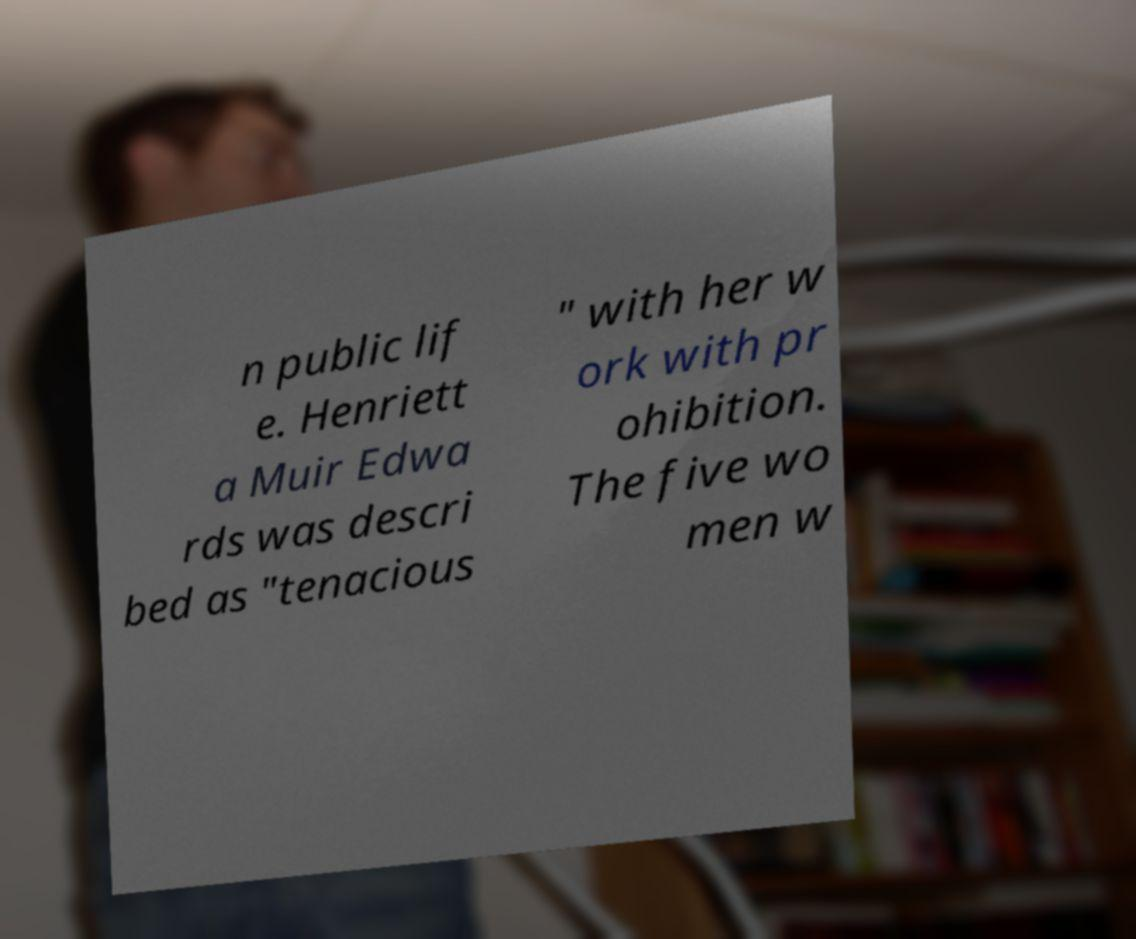I need the written content from this picture converted into text. Can you do that? n public lif e. Henriett a Muir Edwa rds was descri bed as "tenacious " with her w ork with pr ohibition. The five wo men w 